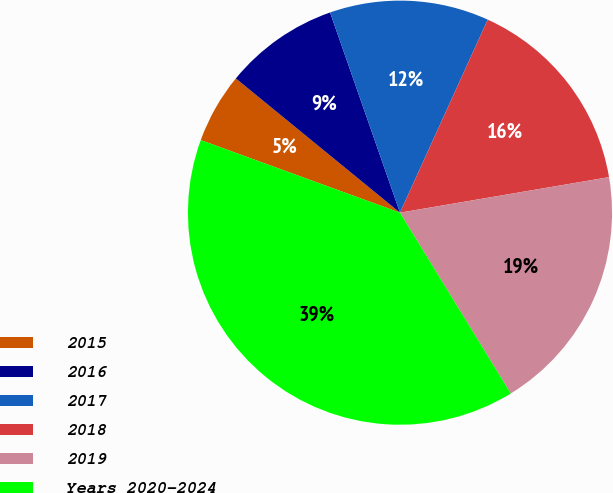Convert chart to OTSL. <chart><loc_0><loc_0><loc_500><loc_500><pie_chart><fcel>2015<fcel>2016<fcel>2017<fcel>2018<fcel>2019<fcel>Years 2020-2024<nl><fcel>5.35%<fcel>8.74%<fcel>12.14%<fcel>15.53%<fcel>18.93%<fcel>39.31%<nl></chart> 